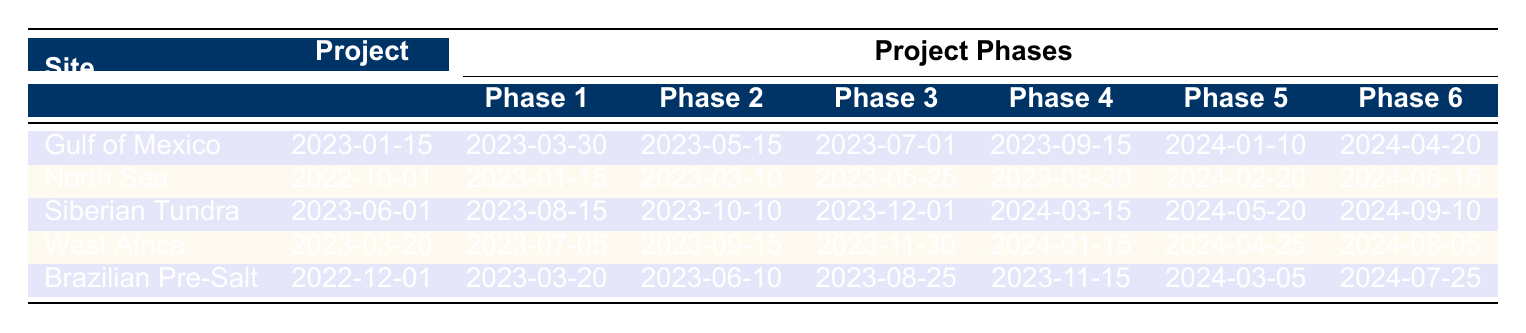What is the project start date for the Gulf of Mexico site? The table indicates that the project start date for the Gulf of Mexico site is listed directly under that site's row, which states "2023-01-15".
Answer: 2023-01-15 Which site has the latest drilling operations start date? To find this, look at the "Phase 5: Drilling Operations Start" for each site. The dates for each are: Gulf of Mexico (2024-01-10), North Sea (2024-02-20), Siberian Tundra (2024-05-20), West Africa (2024-04-25), and Brazilian Pre-Salt (2024-03-05). The latest date is 2024-05-20 for the Siberian Tundra.
Answer: Siberian Tundra How many days are there between the seismic survey completion and the initial production for the North Sea? The dates from the North Sea are: seismic survey completion on "2023-01-15" and initial production on "2024-06-15". Calculating the difference, it is 5 months (January to June), plus the extra days in those months gives (31 + 28 + 31 + 30 + 31) = 151 days, leaving the total as 151 days + 15 days = 166 days from 2023-01-15 to 2024-06-15.
Answer: 166 days Which site completes the data interpretation phase first, and what is the date? To find which site completes the data interpretation phase first, examine the "Phase 2: Data Interpretation" dates for each site. The dates are: Gulf of Mexico (2023-05-15), North Sea (2023-03-10), Siberian Tundra (2023-10-10), West Africa (2023-09-15), and Brazilian Pre-Salt (2023-06-10). The earliest date is for the North Sea on "2023-03-10".
Answer: North Sea, 2023-03-10 Is the initial production date for the Gulf of Mexico before or after that of the Brazilian Pre-Salt? Check the "Phase 6: Initial Production" dates: Gulf of Mexico is "2024-04-20" and Brazilian Pre-Salt is "2024-07-25". Since 2024-04-20 comes before 2024-07-25, the initial production for the Gulf of Mexico is before that of the Brazilian Pre-Salt.
Answer: Before What is the total duration from project start to initial production for the West Africa site? For the West Africa site, the project starts on "2023-03-20" and initial production is on "2024-08-05". Counting the total months and days from March to August gives: March to August is 5 months (March, April, May, June, July, and into August), plus 15 days from the 20th to the 5th equals a total of approximately 1 year, 4 months, and 15 days. In term of days it is (11 days in March + 30 + 31 + 30 + 31 + 5) = 11 + 30 + 31 + 30 + 31 + 5 = 138 days = approx 9 months, giving total time as about 1 year and 4 months.
Answer: 1 year, 4 months Which project phases for the Brazilian Pre-Salt overlap with those of the Gulf of Mexico? Looking at both tables side by side, the overlapping phases are Phase 1: Seismic Survey Completion and Phase 2: Data Interpretation, as these happen between "2023-03-20" and "2023-05-15" (Brazilian Pre-Salt phases overlap with Gulf of Mexico’s phases). Hence, overlapping runs from 2023-03-20 to 2023-05-15.
Answer: Phase 1 and Phase 2 If a new project started in the North Sea one month after the completion of the data interpretation phase, when would that be? The data interpretation for the North Sea finishes on "2023-03-10", one month later it would be "2023-04-10".
Answer: 2023-04-10 